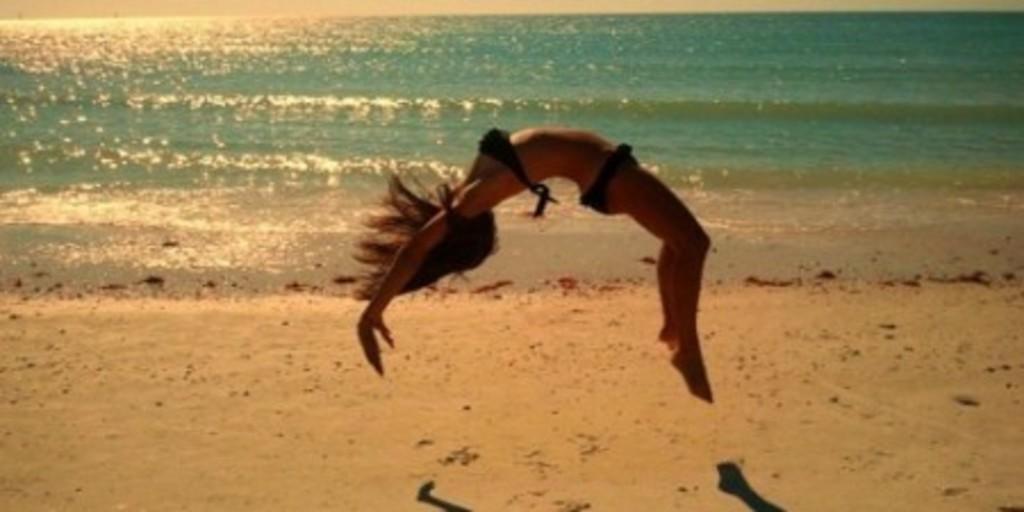Describe this image in one or two sentences. In this image, we can see a lady doing gymnastics and at the bottom, there is water and sand. 